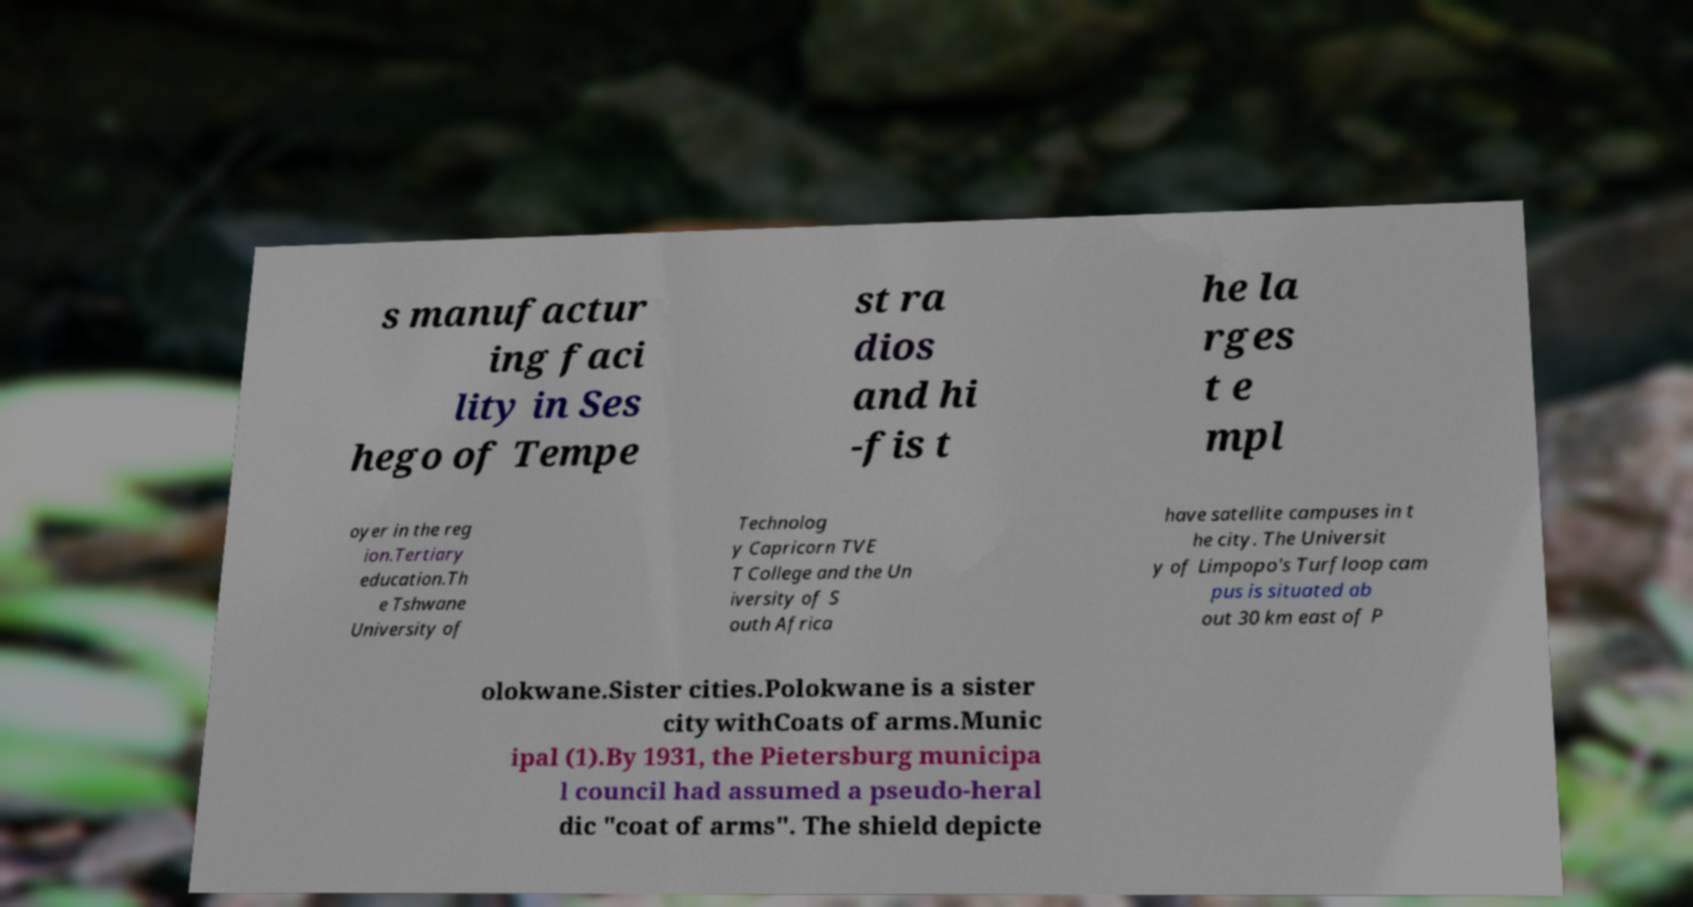I need the written content from this picture converted into text. Can you do that? s manufactur ing faci lity in Ses hego of Tempe st ra dios and hi -fis t he la rges t e mpl oyer in the reg ion.Tertiary education.Th e Tshwane University of Technolog y Capricorn TVE T College and the Un iversity of S outh Africa have satellite campuses in t he city. The Universit y of Limpopo's Turfloop cam pus is situated ab out 30 km east of P olokwane.Sister cities.Polokwane is a sister city withCoats of arms.Munic ipal (1).By 1931, the Pietersburg municipa l council had assumed a pseudo-heral dic "coat of arms". The shield depicte 